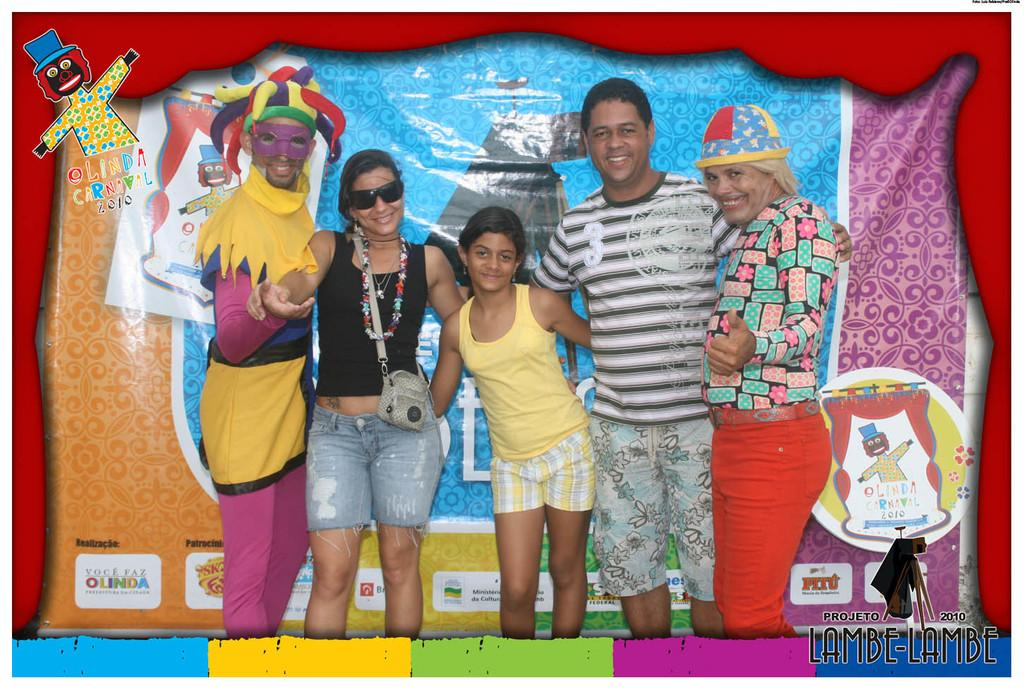What are the people in the image doing? The people in the image are standing in the center and smiling. What can be observed about the people's attire? The people are wearing different costumes. What is present in the background of the image? There is a banner in the background of the image. What type of oil can be seen dripping from the banner in the image? There is no oil present in the image, and the banner does not appear to be dripping anything. 